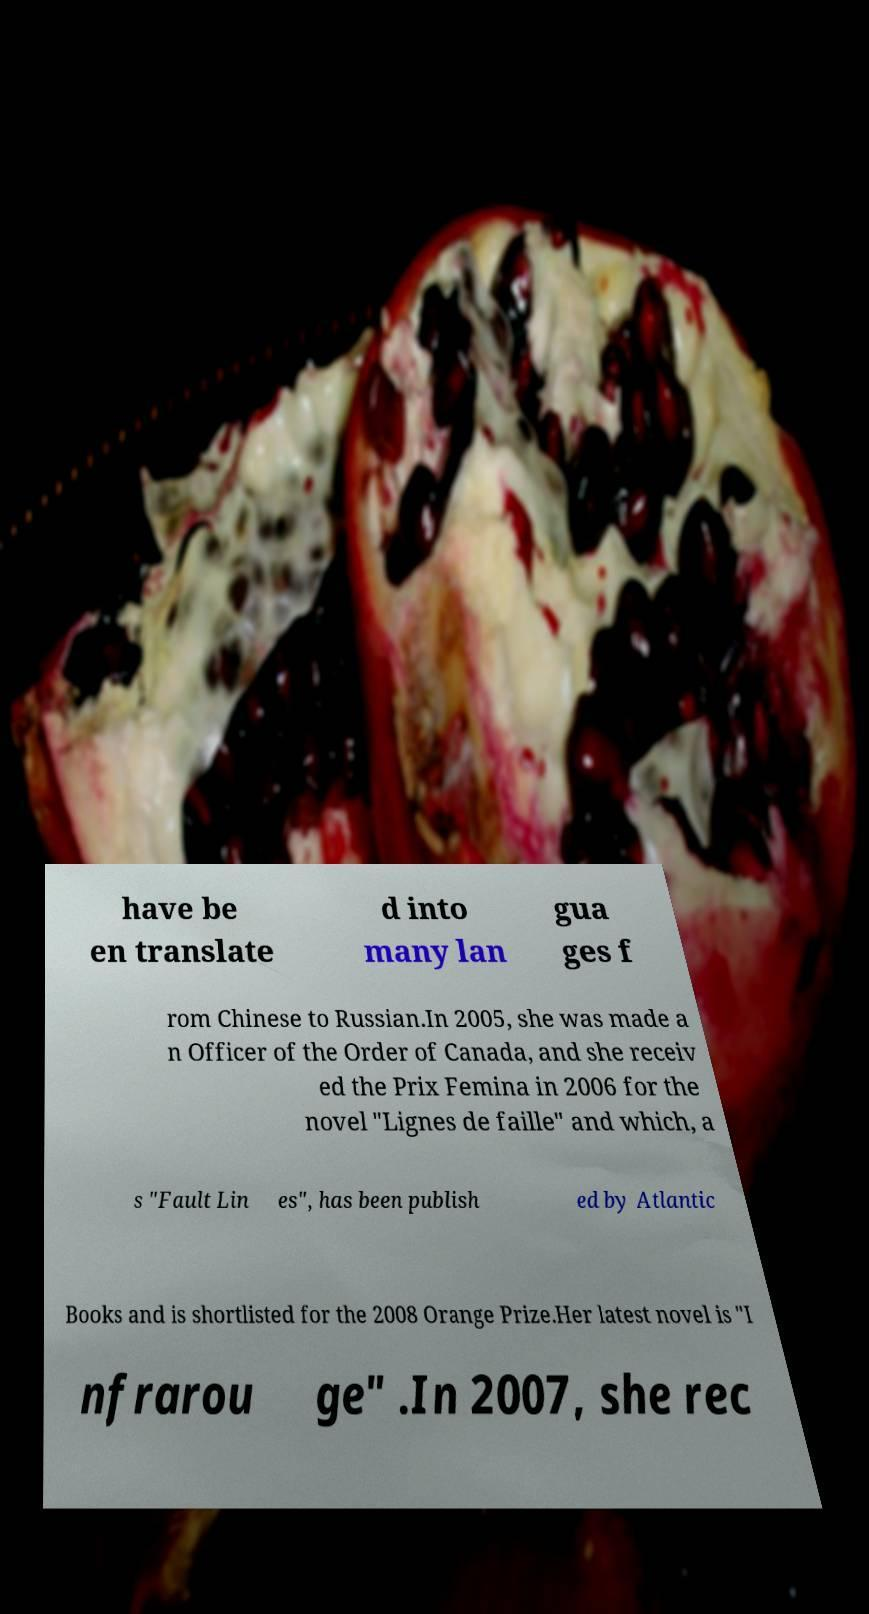For documentation purposes, I need the text within this image transcribed. Could you provide that? have be en translate d into many lan gua ges f rom Chinese to Russian.In 2005, she was made a n Officer of the Order of Canada, and she receiv ed the Prix Femina in 2006 for the novel "Lignes de faille" and which, a s "Fault Lin es", has been publish ed by Atlantic Books and is shortlisted for the 2008 Orange Prize.Her latest novel is "I nfrarou ge" .In 2007, she rec 